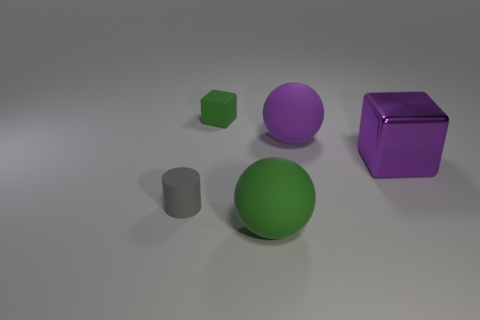Add 4 purple rubber balls. How many objects exist? 9 Subtract all balls. How many objects are left? 3 Subtract 0 cyan cylinders. How many objects are left? 5 Subtract all tiny rubber cubes. Subtract all big green objects. How many objects are left? 3 Add 4 purple blocks. How many purple blocks are left? 5 Add 4 big purple balls. How many big purple balls exist? 5 